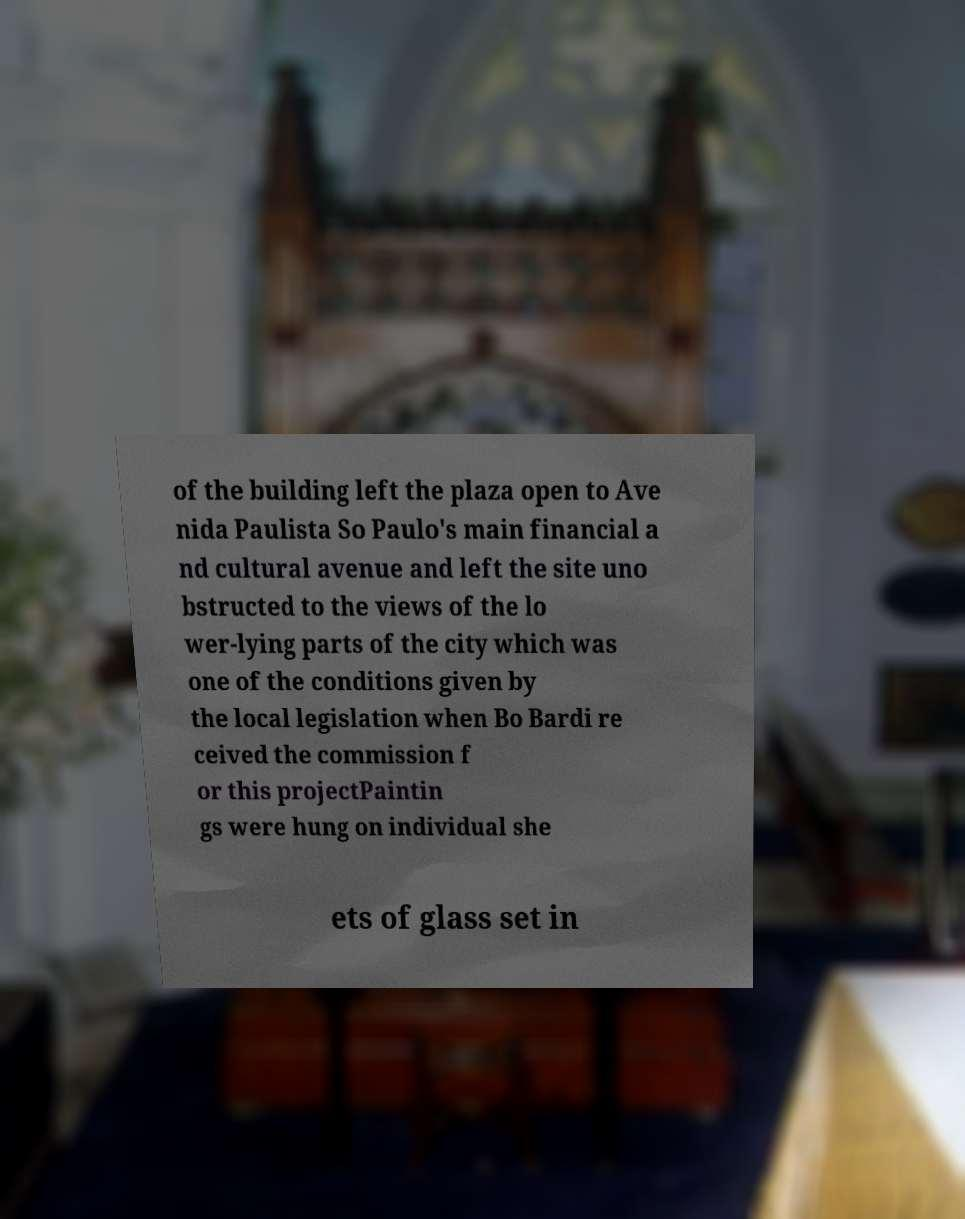What messages or text are displayed in this image? I need them in a readable, typed format. of the building left the plaza open to Ave nida Paulista So Paulo's main financial a nd cultural avenue and left the site uno bstructed to the views of the lo wer-lying parts of the city which was one of the conditions given by the local legislation when Bo Bardi re ceived the commission f or this projectPaintin gs were hung on individual she ets of glass set in 